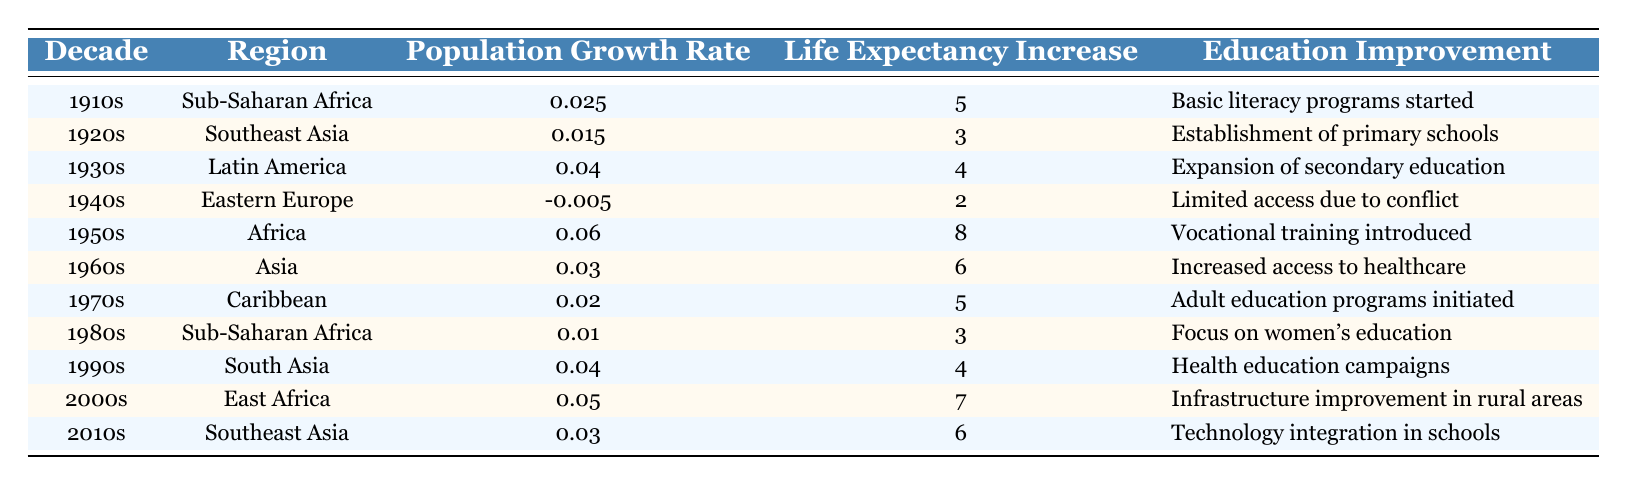What was the population growth rate in the 1950s? The table shows that the population growth rate during the 1950s in Africa was 0.06.
Answer: 0.06 Which decade saw a decline in population growth, and what was the rate? The table indicates that the Eastern Europe in the 1940s experienced a decline, with a population growth rate of -0.005.
Answer: 1940s, -0.005 What's the average life expectancy increase from the 1910s to the 2010s? Adding the life expectancy increases for the decades: 5 + 3 + 4 + 2 + 8 + 6 + 5 + 3 + 4 + 7 + 6 = 53 and then dividing by the number of decades, which is 11, gives an average increase of 53/11 = 4.818, rounded to 4.82.
Answer: 4.82 True or false: The 1930s had the highest life expectancy increase among the listed decades. The life expectancy increases for the decades show that the highest increase occurred in the 1950s (8), which is higher than the 4 in the 1930s. Therefore, the statement is false.
Answer: False Which region had the lowest population growth rate in the 1920s and what was the impact? In the 1920s, Southeast Asia had a population growth rate of 0.015, which is higher than multiple other decades, but among the listed decades, it isn't the lowest. As the 1940s had a decline, the subsequent comparison shows Southeast Asia was low during the 20s while Eastern Europe was the only decline.
Answer: Southeast Asia, 0.015 